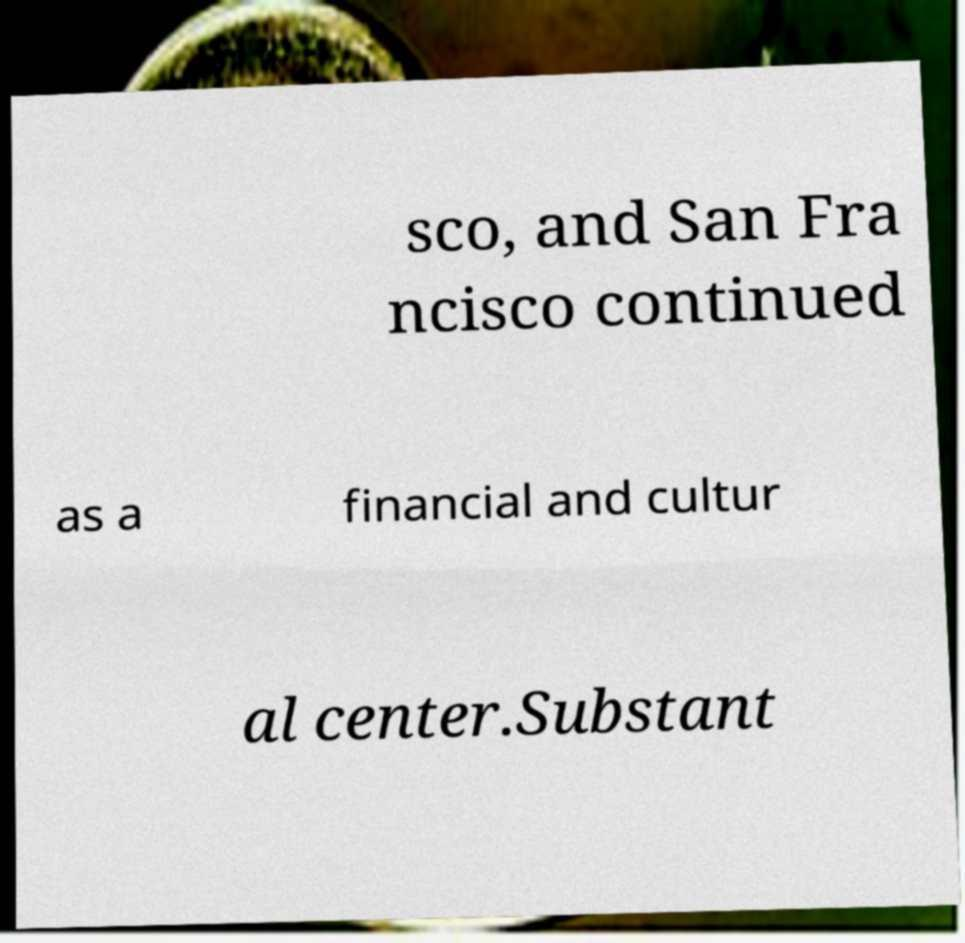Could you extract and type out the text from this image? sco, and San Fra ncisco continued as a financial and cultur al center.Substant 